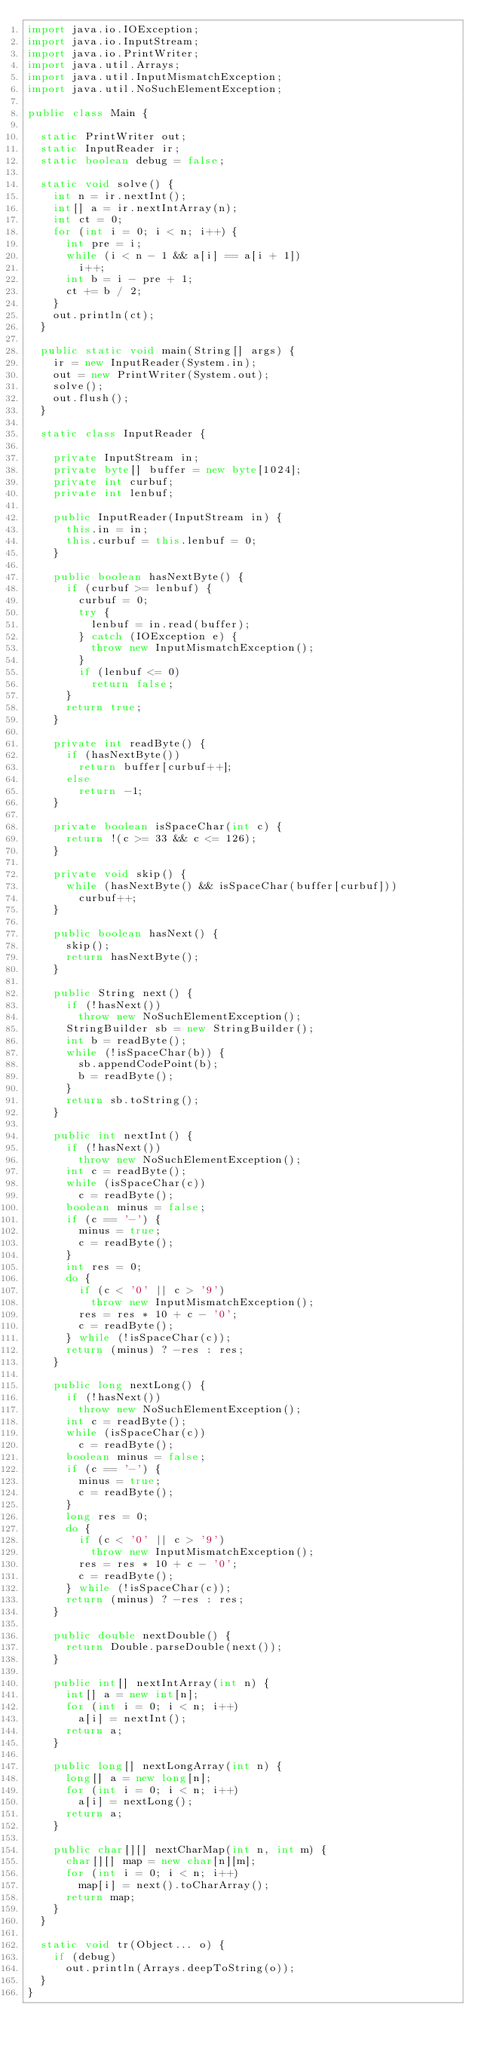<code> <loc_0><loc_0><loc_500><loc_500><_Java_>import java.io.IOException;
import java.io.InputStream;
import java.io.PrintWriter;
import java.util.Arrays;
import java.util.InputMismatchException;
import java.util.NoSuchElementException;

public class Main {

	static PrintWriter out;
	static InputReader ir;
	static boolean debug = false;

	static void solve() {
		int n = ir.nextInt();
		int[] a = ir.nextIntArray(n);
		int ct = 0;
		for (int i = 0; i < n; i++) {
			int pre = i;
			while (i < n - 1 && a[i] == a[i + 1])
				i++;
			int b = i - pre + 1;
			ct += b / 2;
		}
		out.println(ct);
	}

	public static void main(String[] args) {
		ir = new InputReader(System.in);
		out = new PrintWriter(System.out);
		solve();
		out.flush();
	}

	static class InputReader {

		private InputStream in;
		private byte[] buffer = new byte[1024];
		private int curbuf;
		private int lenbuf;

		public InputReader(InputStream in) {
			this.in = in;
			this.curbuf = this.lenbuf = 0;
		}

		public boolean hasNextByte() {
			if (curbuf >= lenbuf) {
				curbuf = 0;
				try {
					lenbuf = in.read(buffer);
				} catch (IOException e) {
					throw new InputMismatchException();
				}
				if (lenbuf <= 0)
					return false;
			}
			return true;
		}

		private int readByte() {
			if (hasNextByte())
				return buffer[curbuf++];
			else
				return -1;
		}

		private boolean isSpaceChar(int c) {
			return !(c >= 33 && c <= 126);
		}

		private void skip() {
			while (hasNextByte() && isSpaceChar(buffer[curbuf]))
				curbuf++;
		}

		public boolean hasNext() {
			skip();
			return hasNextByte();
		}

		public String next() {
			if (!hasNext())
				throw new NoSuchElementException();
			StringBuilder sb = new StringBuilder();
			int b = readByte();
			while (!isSpaceChar(b)) {
				sb.appendCodePoint(b);
				b = readByte();
			}
			return sb.toString();
		}

		public int nextInt() {
			if (!hasNext())
				throw new NoSuchElementException();
			int c = readByte();
			while (isSpaceChar(c))
				c = readByte();
			boolean minus = false;
			if (c == '-') {
				minus = true;
				c = readByte();
			}
			int res = 0;
			do {
				if (c < '0' || c > '9')
					throw new InputMismatchException();
				res = res * 10 + c - '0';
				c = readByte();
			} while (!isSpaceChar(c));
			return (minus) ? -res : res;
		}

		public long nextLong() {
			if (!hasNext())
				throw new NoSuchElementException();
			int c = readByte();
			while (isSpaceChar(c))
				c = readByte();
			boolean minus = false;
			if (c == '-') {
				minus = true;
				c = readByte();
			}
			long res = 0;
			do {
				if (c < '0' || c > '9')
					throw new InputMismatchException();
				res = res * 10 + c - '0';
				c = readByte();
			} while (!isSpaceChar(c));
			return (minus) ? -res : res;
		}

		public double nextDouble() {
			return Double.parseDouble(next());
		}

		public int[] nextIntArray(int n) {
			int[] a = new int[n];
			for (int i = 0; i < n; i++)
				a[i] = nextInt();
			return a;
		}

		public long[] nextLongArray(int n) {
			long[] a = new long[n];
			for (int i = 0; i < n; i++)
				a[i] = nextLong();
			return a;
		}

		public char[][] nextCharMap(int n, int m) {
			char[][] map = new char[n][m];
			for (int i = 0; i < n; i++)
				map[i] = next().toCharArray();
			return map;
		}
	}

	static void tr(Object... o) {
		if (debug)
			out.println(Arrays.deepToString(o));
	}
}
</code> 